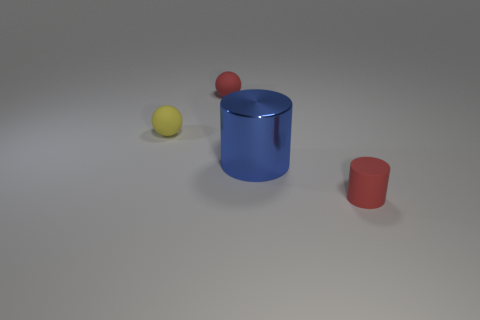Is there any other thing that has the same material as the blue thing?
Your answer should be compact. No. Are there fewer red rubber things in front of the tiny red rubber cylinder than small red spheres that are to the right of the red sphere?
Provide a succinct answer. No. What number of matte objects are either cylinders or small things?
Offer a terse response. 3. The blue shiny thing has what shape?
Ensure brevity in your answer.  Cylinder. There is a red ball that is the same size as the yellow matte ball; what is it made of?
Provide a succinct answer. Rubber. How many small objects are either red metallic cylinders or red rubber things?
Your answer should be compact. 2. Are any big cylinders visible?
Keep it short and to the point. Yes. There is a cylinder that is made of the same material as the yellow ball; what size is it?
Make the answer very short. Small. Do the blue thing and the red sphere have the same material?
Provide a short and direct response. No. How many other things are there of the same material as the large object?
Ensure brevity in your answer.  0. 